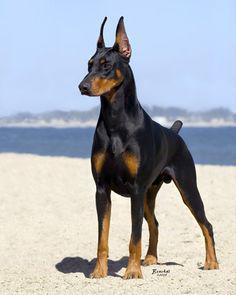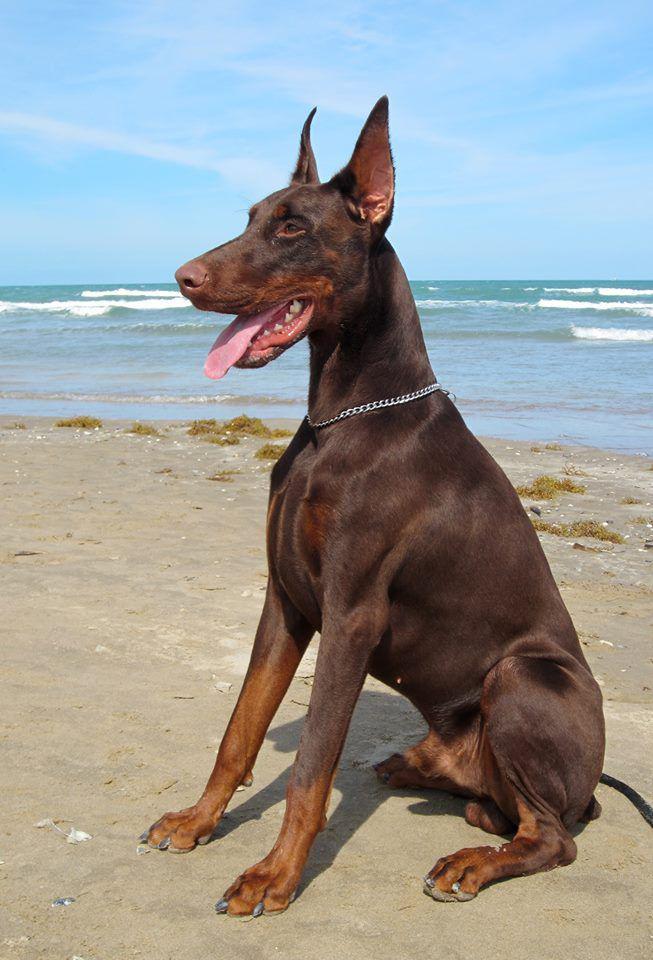The first image is the image on the left, the second image is the image on the right. For the images displayed, is the sentence "Only one dog has a collar on" factually correct? Answer yes or no. Yes. The first image is the image on the left, the second image is the image on the right. Considering the images on both sides, is "All dogs gaze leftward and are dobermans with erect ears, and one dog has its mouth open and tongue hanging past its lower lip." valid? Answer yes or no. Yes. 